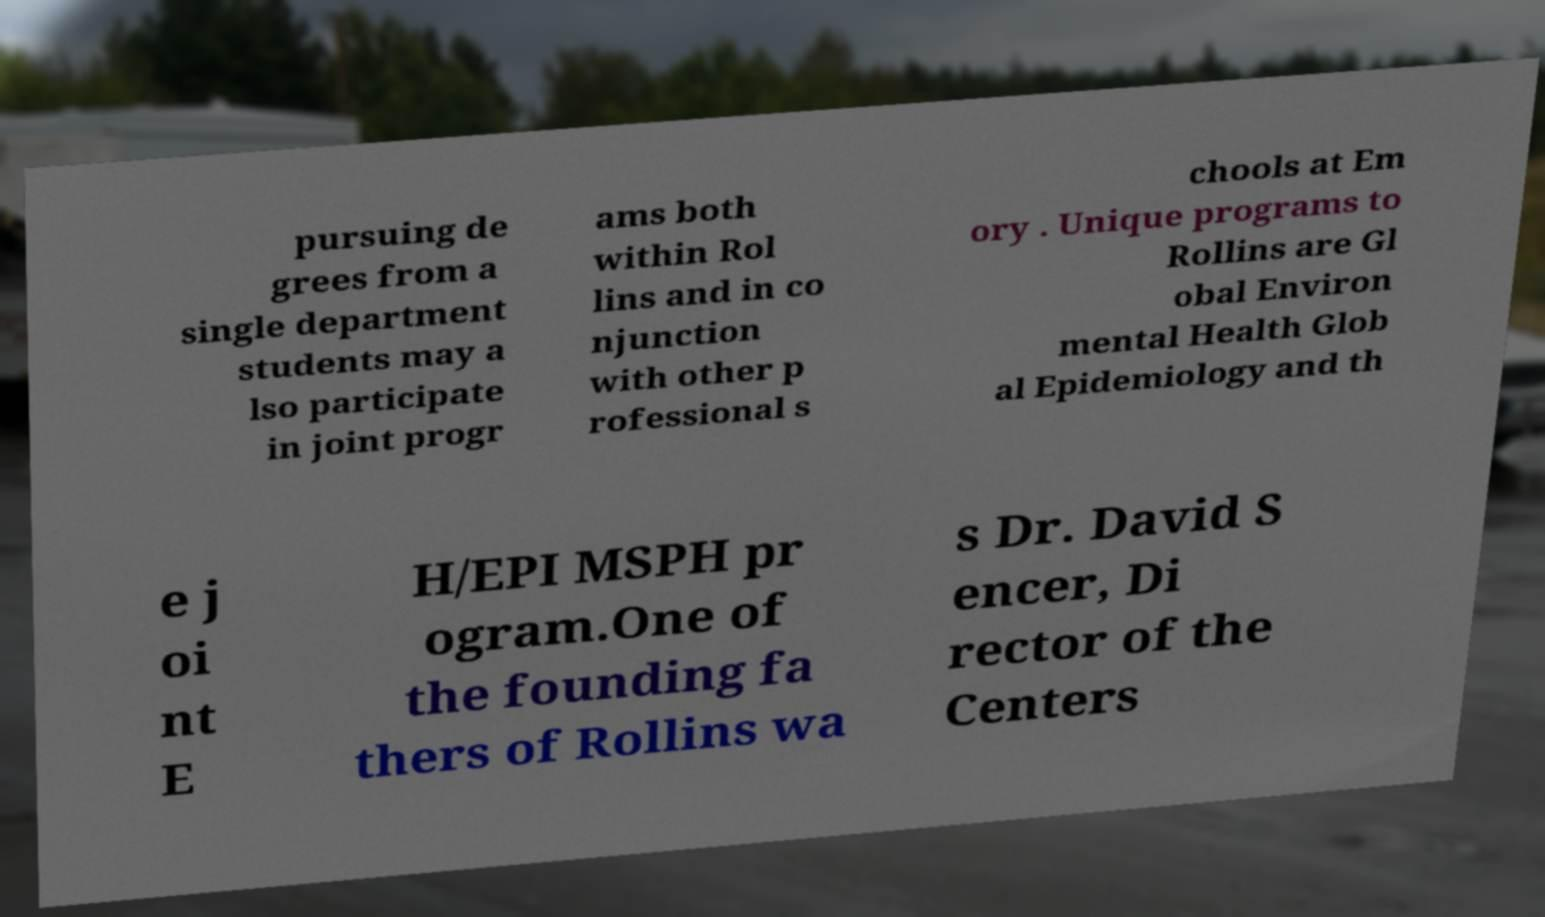For documentation purposes, I need the text within this image transcribed. Could you provide that? pursuing de grees from a single department students may a lso participate in joint progr ams both within Rol lins and in co njunction with other p rofessional s chools at Em ory . Unique programs to Rollins are Gl obal Environ mental Health Glob al Epidemiology and th e j oi nt E H/EPI MSPH pr ogram.One of the founding fa thers of Rollins wa s Dr. David S encer, Di rector of the Centers 